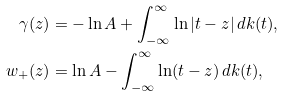<formula> <loc_0><loc_0><loc_500><loc_500>\gamma ( z ) & = - \ln A + \int _ { - \infty } ^ { \infty } \ln | t - z | \, d k ( t ) , \\ w _ { + } ( z ) & = \ln A - \int _ { - \infty } ^ { \infty } \ln ( t - z ) \, d k ( t ) ,</formula> 